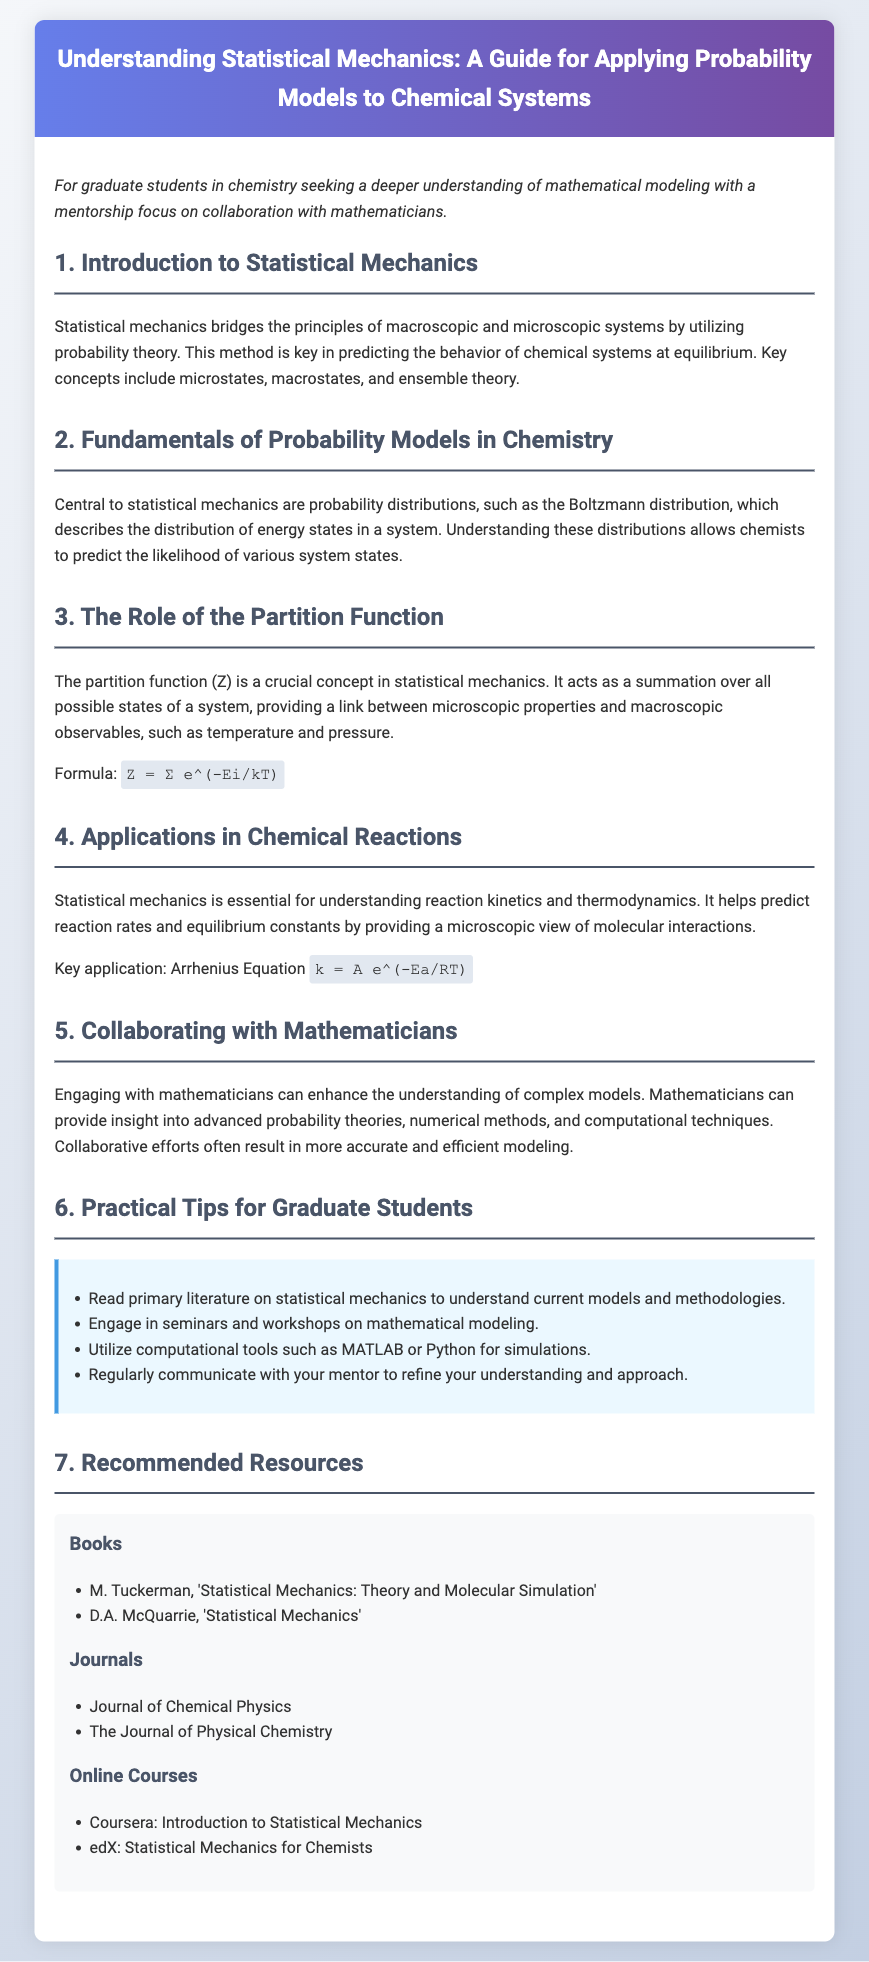What is the main purpose of this guide? The main purpose is to help graduate students in chemistry seeking a deeper understanding of mathematical modeling with a mentorship focus.
Answer: Deeper understanding of mathematical modeling What formula represents the partition function? The partition function is represented by the formula shown in section 3, linking microscopic and macroscopic properties.
Answer: Z = Σ e^(-Ei/kT) Who is the author of "Statistical Mechanics: Theory and Molecular Simulation"? This book is listed in the recommended resources, specifically under the 'Books' section, indicating its relevance to the user guide.
Answer: M. Tuckerman What is a key application of statistical mechanics mentioned? This application is discussed in section 4, highlighting its significance in predicting essential chemical behavior.
Answer: Arrhenius Equation What does the Boltzmann distribution describe? This concept is introduced in section 2 and is essential for understanding energy state distributions in chemical systems.
Answer: Distribution of energy states What should students regularly do to enhance their learning? This is mentioned in section 6, suggesting a proactive approach to refine understanding in statistical mechanics.
Answer: Communicate with your mentor What is one computational tool recommended for simulations? This recommendation is part of the practical tips in section 6, focusing on tools that will aid in simulations and modeling.
Answer: MATLAB or Python Which journal is recommended for research in this field? The guide lists various journals under recommended resources, indicating places to find relevant studies and articles.
Answer: Journal of Chemical Physics 